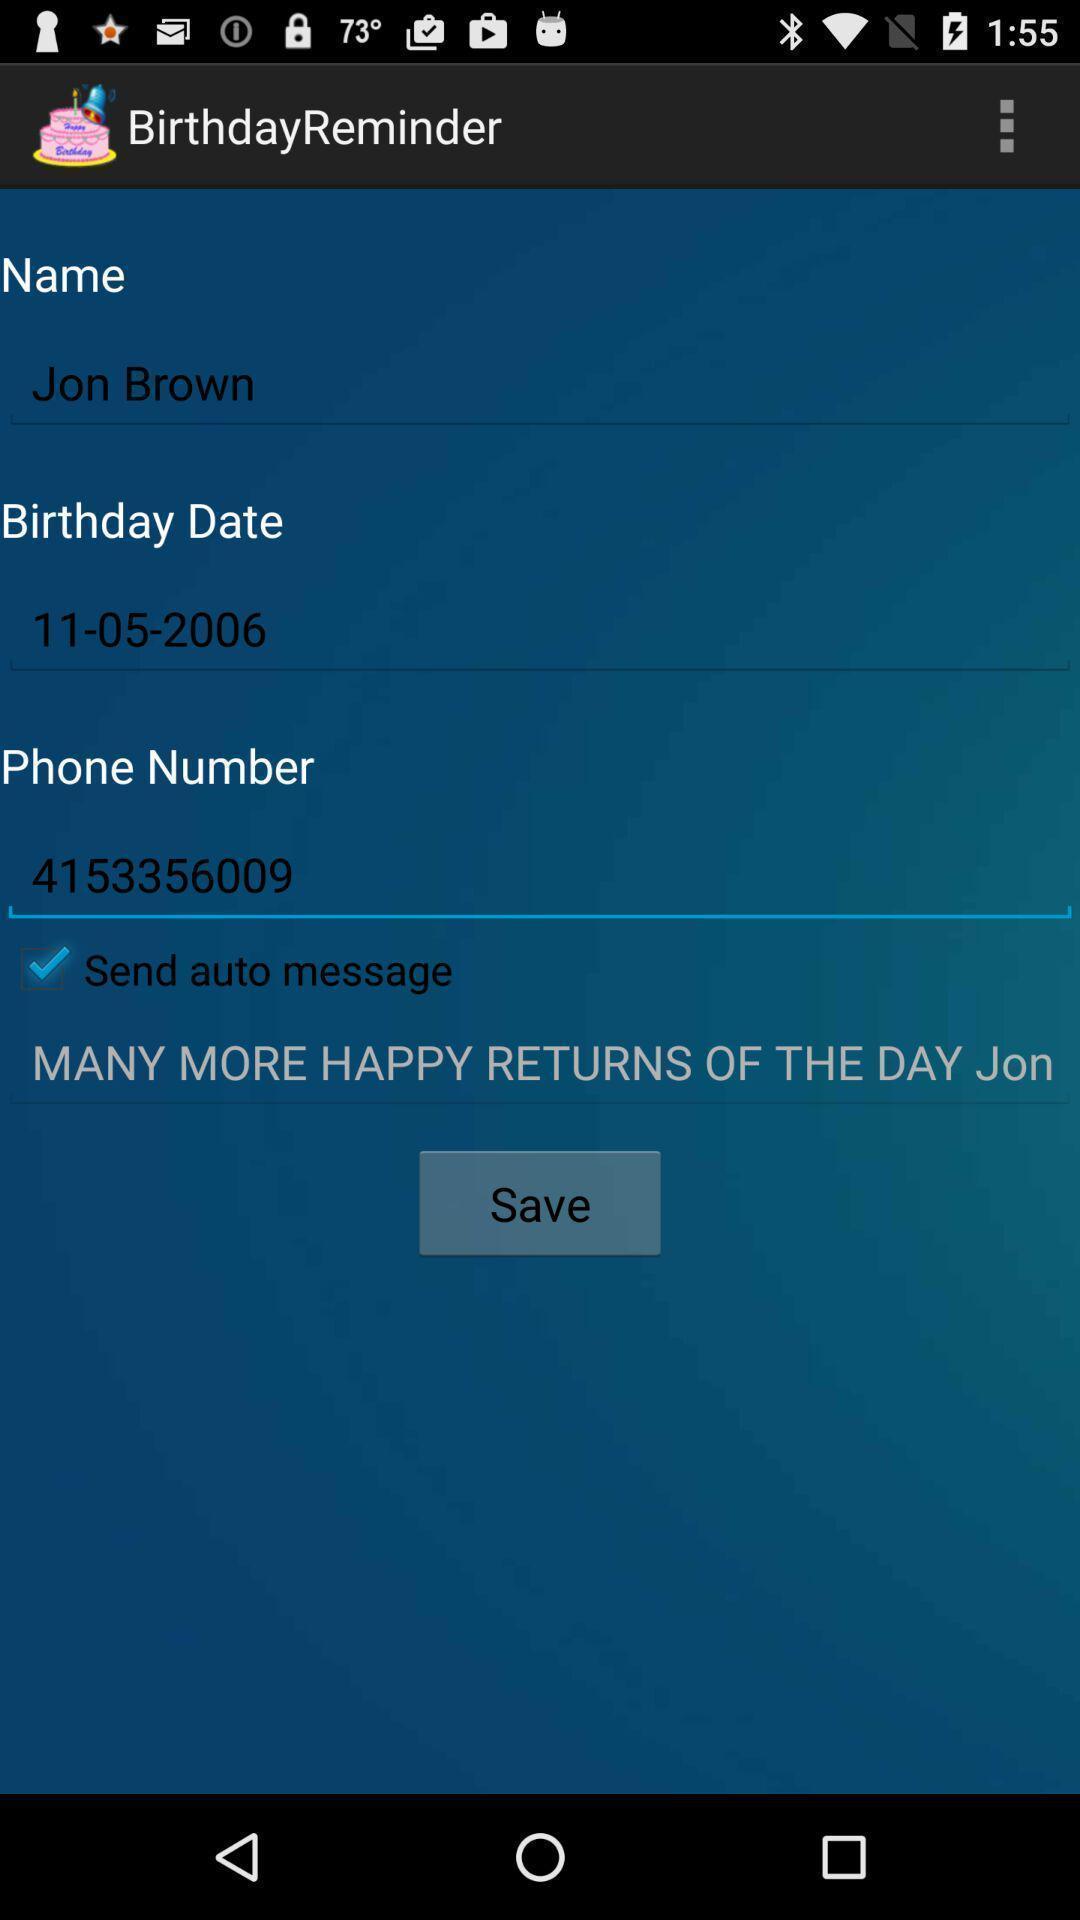Describe this image in words. Screen showing the input options in remainder app. 